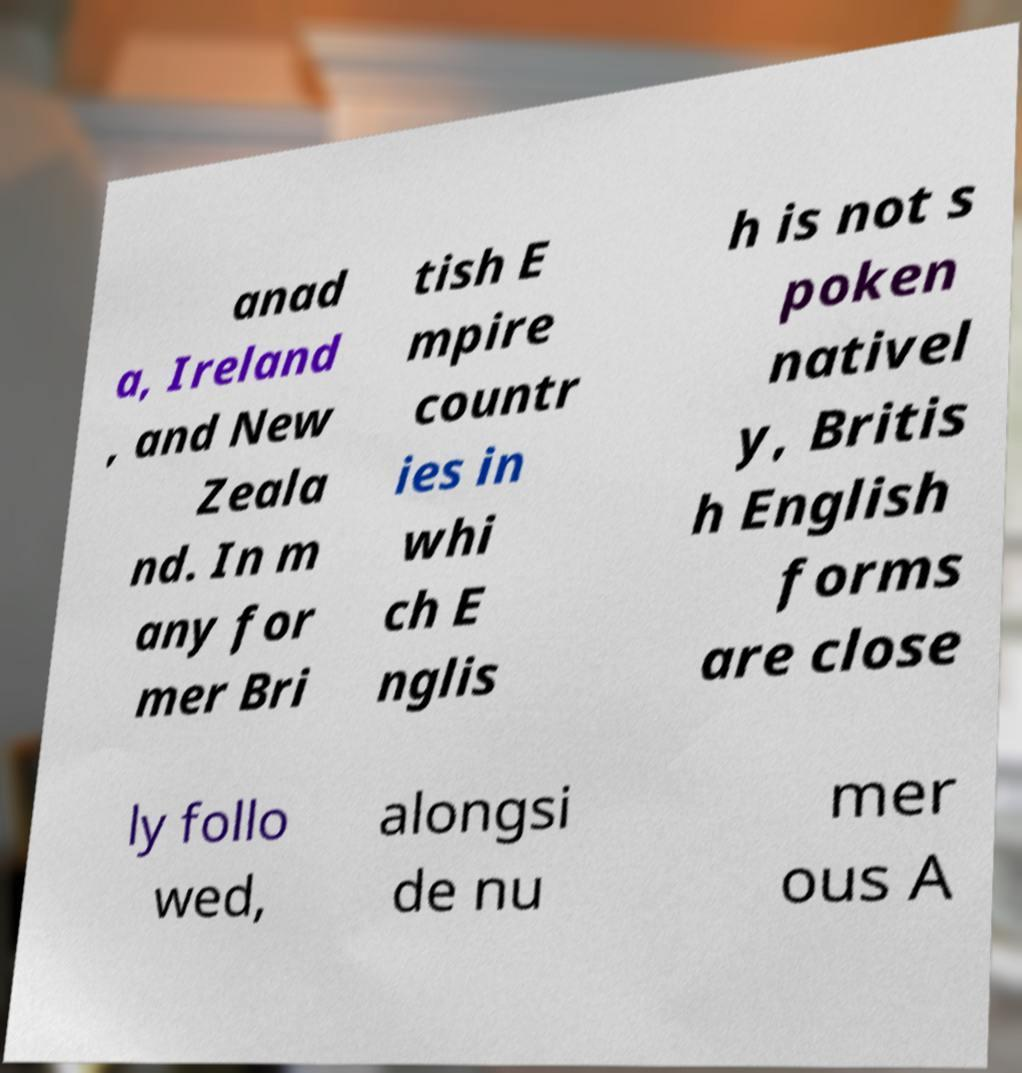Could you extract and type out the text from this image? anad a, Ireland , and New Zeala nd. In m any for mer Bri tish E mpire countr ies in whi ch E nglis h is not s poken nativel y, Britis h English forms are close ly follo wed, alongsi de nu mer ous A 